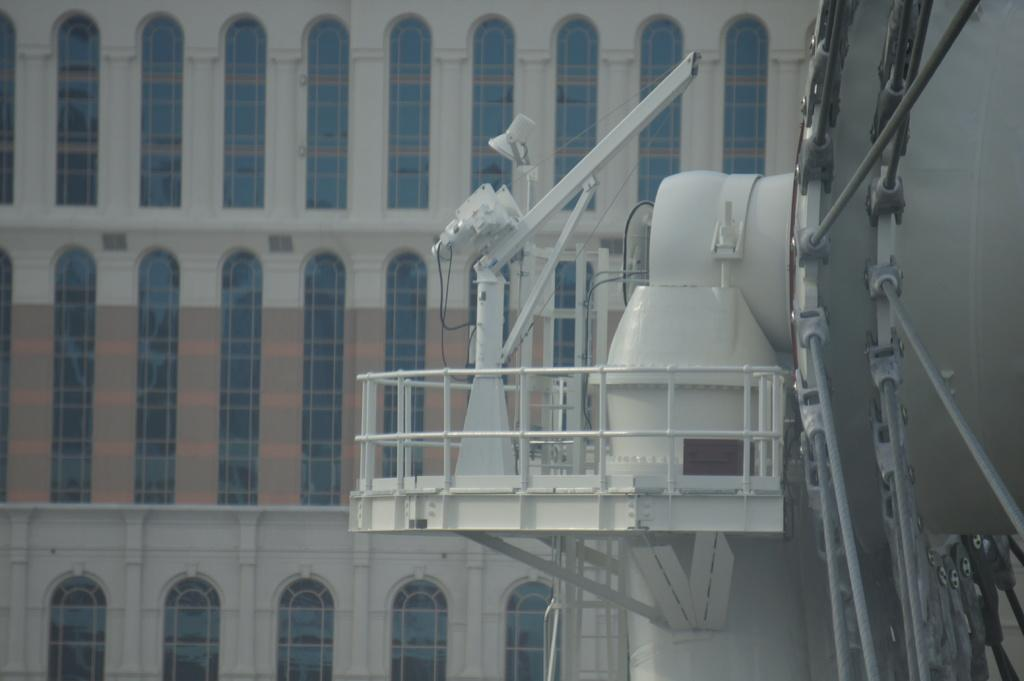What type of structure is visible in the image? There is a building in the image. Can you describe any specific features of the building? Unfortunately, the provided facts do not mention any specific features of the building. Are there any other objects or elements in the image besides the building? Yes, there is an object in white color in the image. What book is the person reading in the image? There is no person or book present in the image, so it is not possible to answer that question. 